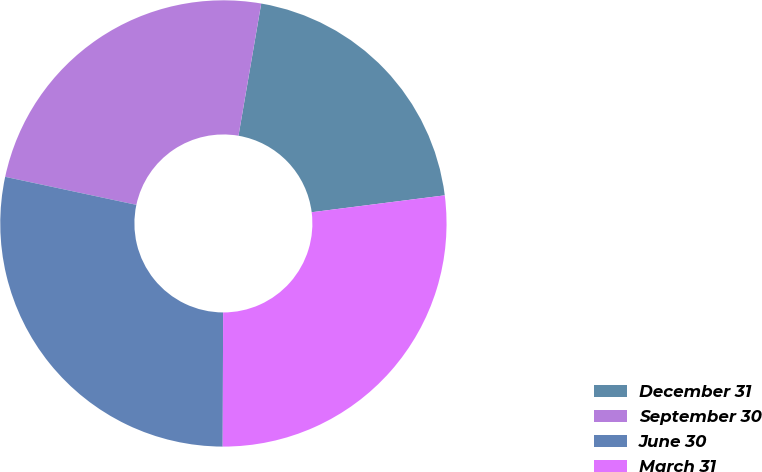Convert chart. <chart><loc_0><loc_0><loc_500><loc_500><pie_chart><fcel>December 31<fcel>September 30<fcel>June 30<fcel>March 31<nl><fcel>20.28%<fcel>24.36%<fcel>28.3%<fcel>27.06%<nl></chart> 